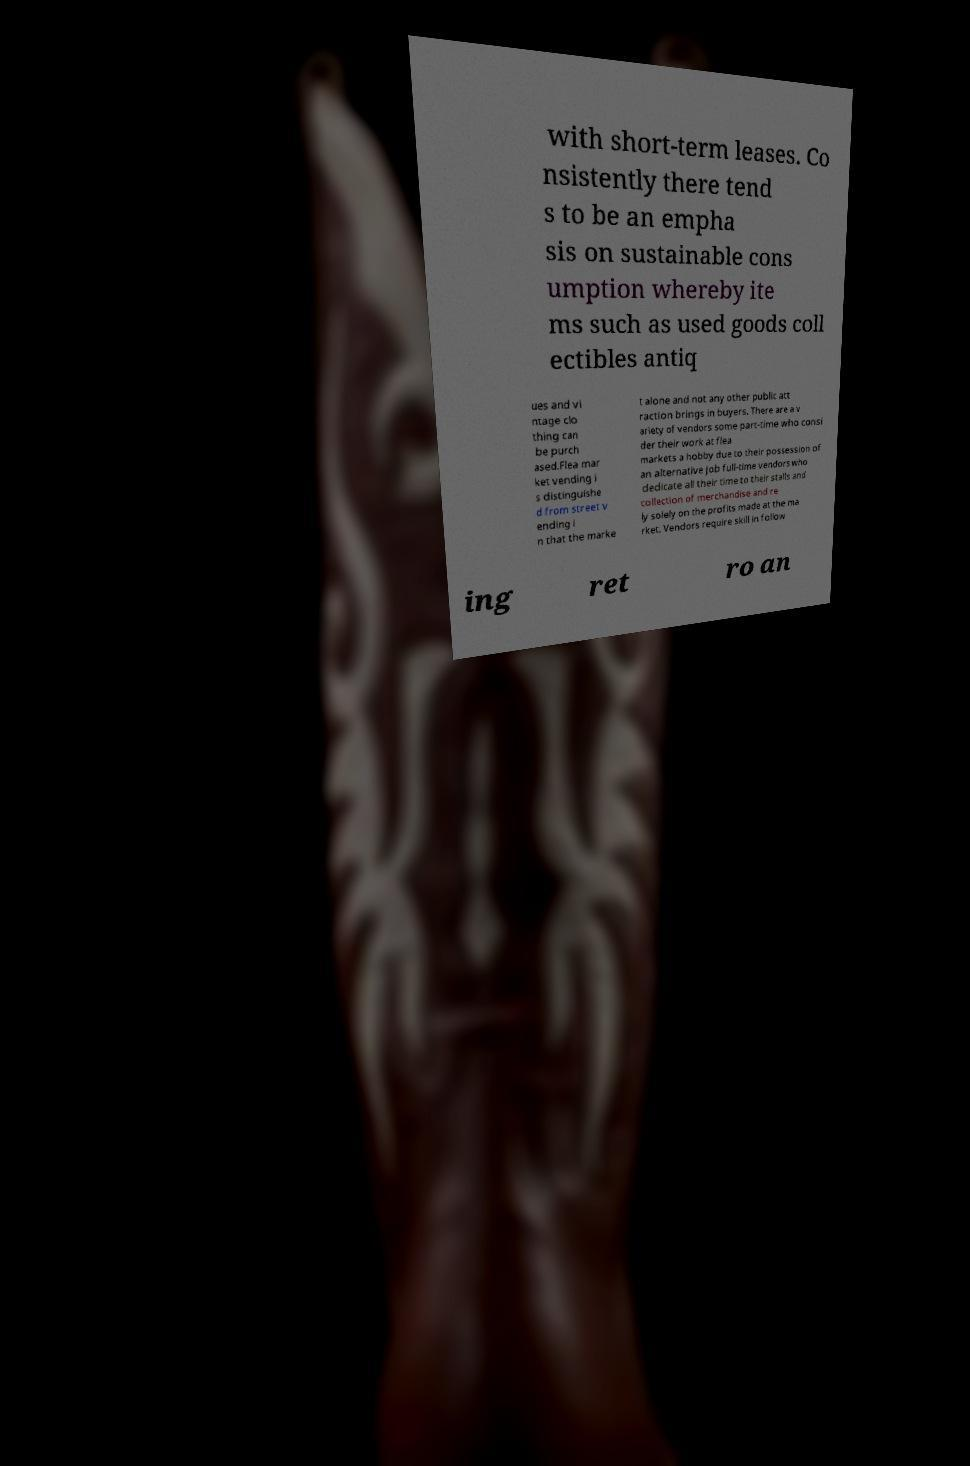Can you read and provide the text displayed in the image?This photo seems to have some interesting text. Can you extract and type it out for me? with short-term leases. Co nsistently there tend s to be an empha sis on sustainable cons umption whereby ite ms such as used goods coll ectibles antiq ues and vi ntage clo thing can be purch ased.Flea mar ket vending i s distinguishe d from street v ending i n that the marke t alone and not any other public att raction brings in buyers. There are a v ariety of vendors some part-time who consi der their work at flea markets a hobby due to their possession of an alternative job full-time vendors who dedicate all their time to their stalls and collection of merchandise and re ly solely on the profits made at the ma rket. Vendors require skill in follow ing ret ro an 